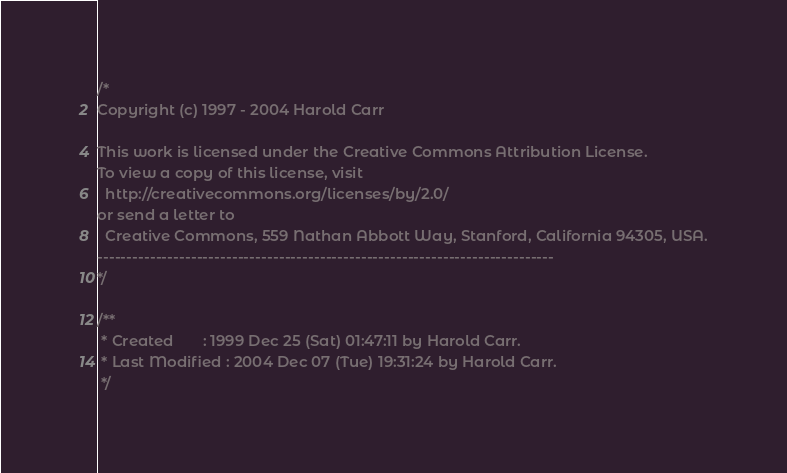<code> <loc_0><loc_0><loc_500><loc_500><_Java_>/*
Copyright (c) 1997 - 2004 Harold Carr

This work is licensed under the Creative Commons Attribution License.
To view a copy of this license, visit 
  http://creativecommons.org/licenses/by/2.0/
or send a letter to
  Creative Commons, 559 Nathan Abbott Way, Stanford, California 94305, USA.
------------------------------------------------------------------------------
*/

/**
 * Created       : 1999 Dec 25 (Sat) 01:47:11 by Harold Carr.
 * Last Modified : 2004 Dec 07 (Tue) 19:31:24 by Harold Carr.
 */
</code> 